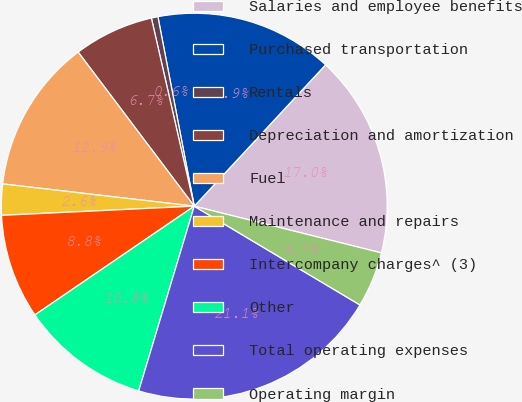Convert chart to OTSL. <chart><loc_0><loc_0><loc_500><loc_500><pie_chart><fcel>Salaries and employee benefits<fcel>Purchased transportation<fcel>Rentals<fcel>Depreciation and amortization<fcel>Fuel<fcel>Maintenance and repairs<fcel>Intercompany charges^ (3)<fcel>Other<fcel>Total operating expenses<fcel>Operating margin<nl><fcel>16.98%<fcel>14.93%<fcel>0.55%<fcel>6.71%<fcel>12.88%<fcel>2.6%<fcel>8.77%<fcel>10.82%<fcel>21.09%<fcel>4.66%<nl></chart> 